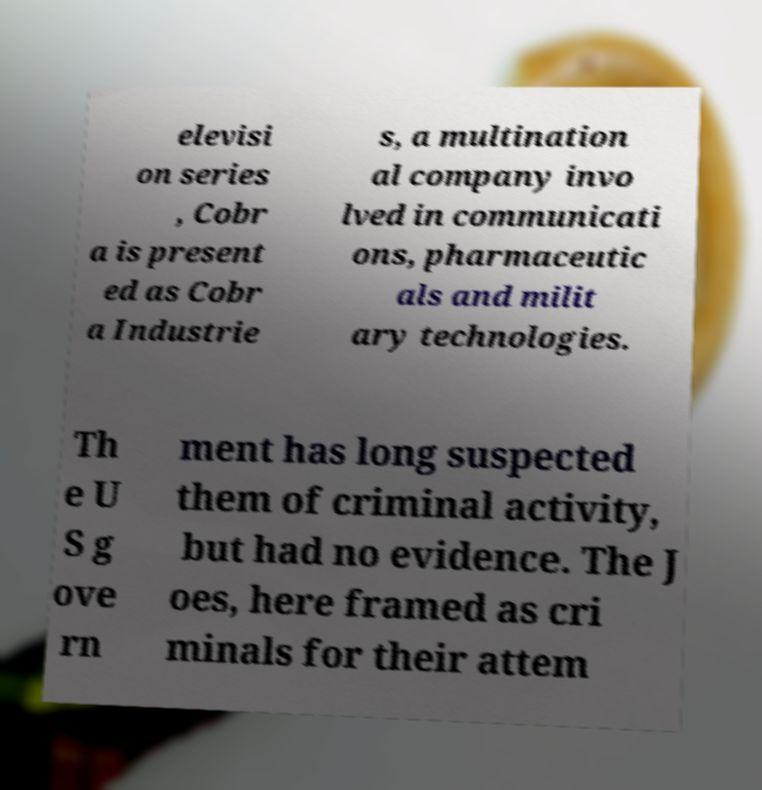Can you read and provide the text displayed in the image?This photo seems to have some interesting text. Can you extract and type it out for me? elevisi on series , Cobr a is present ed as Cobr a Industrie s, a multination al company invo lved in communicati ons, pharmaceutic als and milit ary technologies. Th e U S g ove rn ment has long suspected them of criminal activity, but had no evidence. The J oes, here framed as cri minals for their attem 